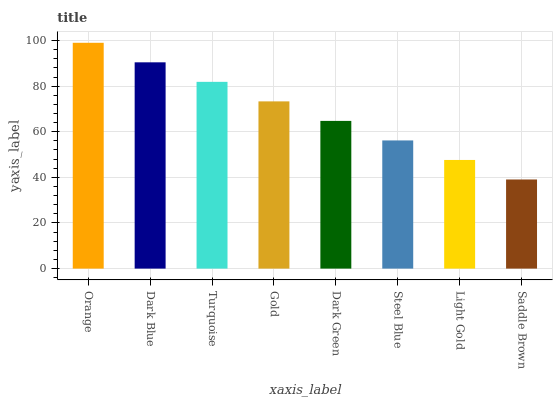Is Saddle Brown the minimum?
Answer yes or no. Yes. Is Orange the maximum?
Answer yes or no. Yes. Is Dark Blue the minimum?
Answer yes or no. No. Is Dark Blue the maximum?
Answer yes or no. No. Is Orange greater than Dark Blue?
Answer yes or no. Yes. Is Dark Blue less than Orange?
Answer yes or no. Yes. Is Dark Blue greater than Orange?
Answer yes or no. No. Is Orange less than Dark Blue?
Answer yes or no. No. Is Gold the high median?
Answer yes or no. Yes. Is Dark Green the low median?
Answer yes or no. Yes. Is Steel Blue the high median?
Answer yes or no. No. Is Gold the low median?
Answer yes or no. No. 